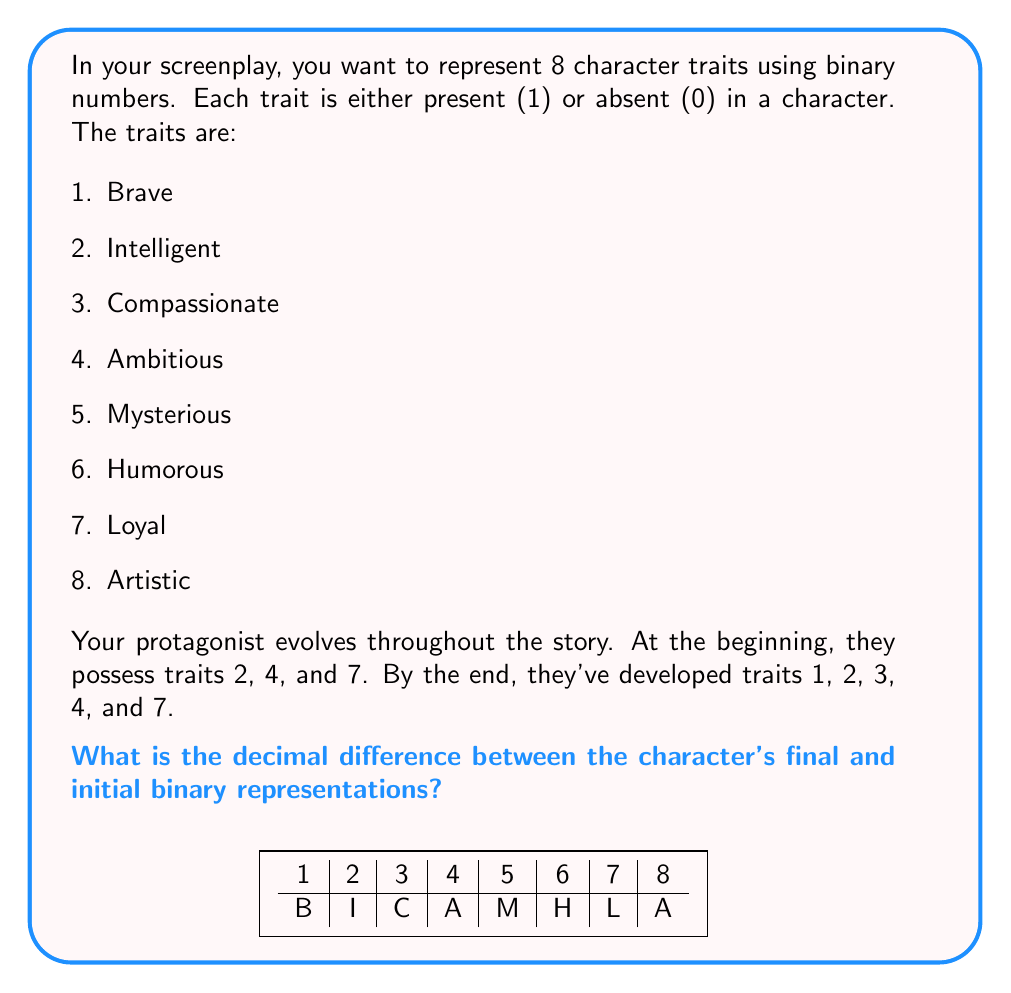Can you answer this question? Let's approach this step-by-step:

1. Initial character traits:
   - Traits present: 2 (Intelligent), 4 (Ambitious), 7 (Loyal)
   - Binary representation: $01010010$

2. Final character traits:
   - Traits present: 1 (Brave), 2 (Intelligent), 3 (Compassionate), 4 (Ambitious), 7 (Loyal)
   - Binary representation: $11110010$

3. Convert initial binary to decimal:
   $01010010_2 = 0\cdot2^7 + 1\cdot2^6 + 0\cdot2^5 + 1\cdot2^4 + 0\cdot2^3 + 0\cdot2^2 + 1\cdot2^1 + 0\cdot2^0 = 64 + 16 + 2 = 82$

4. Convert final binary to decimal:
   $11110010_2 = 1\cdot2^7 + 1\cdot2^6 + 1\cdot2^5 + 1\cdot2^4 + 0\cdot2^3 + 0\cdot2^2 + 1\cdot2^1 + 0\cdot2^0 = 128 + 64 + 32 + 16 + 2 = 242$

5. Calculate the difference:
   $242 - 82 = 160$

Thus, the decimal difference between the character's final and initial binary representations is 160.
Answer: 160 